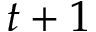Convert formula to latex. <formula><loc_0><loc_0><loc_500><loc_500>t + 1</formula> 